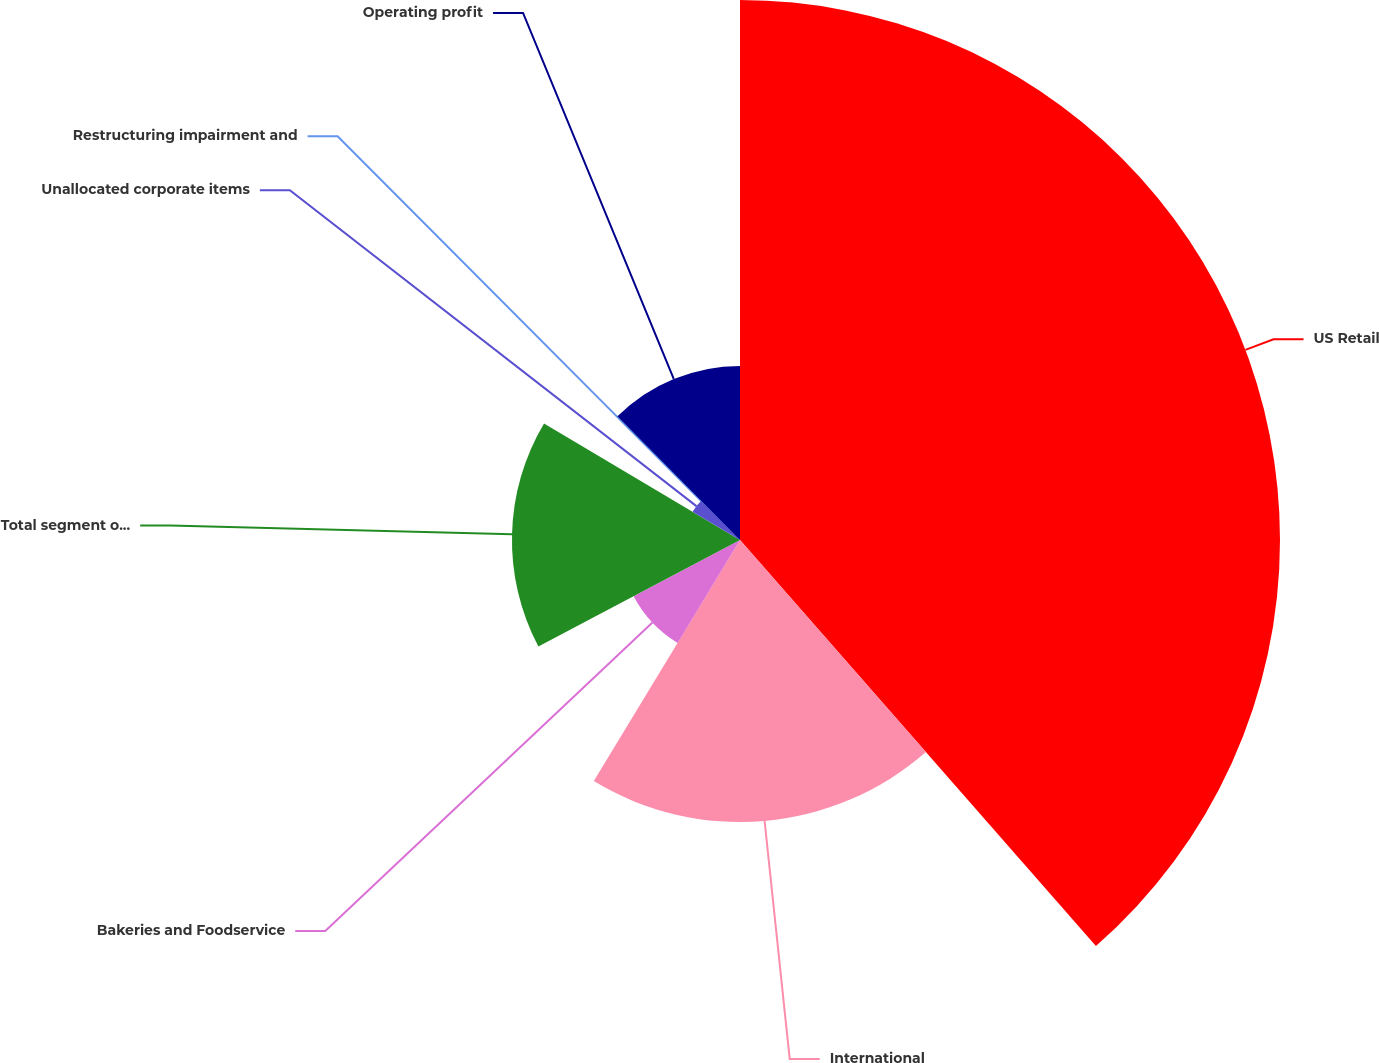Convert chart to OTSL. <chart><loc_0><loc_0><loc_500><loc_500><pie_chart><fcel>US Retail<fcel>International<fcel>Bakeries and Foodservice<fcel>Total segment operating profit<fcel>Unallocated corporate items<fcel>Restructuring impairment and<fcel>Operating profit<nl><fcel>38.55%<fcel>20.13%<fcel>8.59%<fcel>16.28%<fcel>3.94%<fcel>0.09%<fcel>12.43%<nl></chart> 